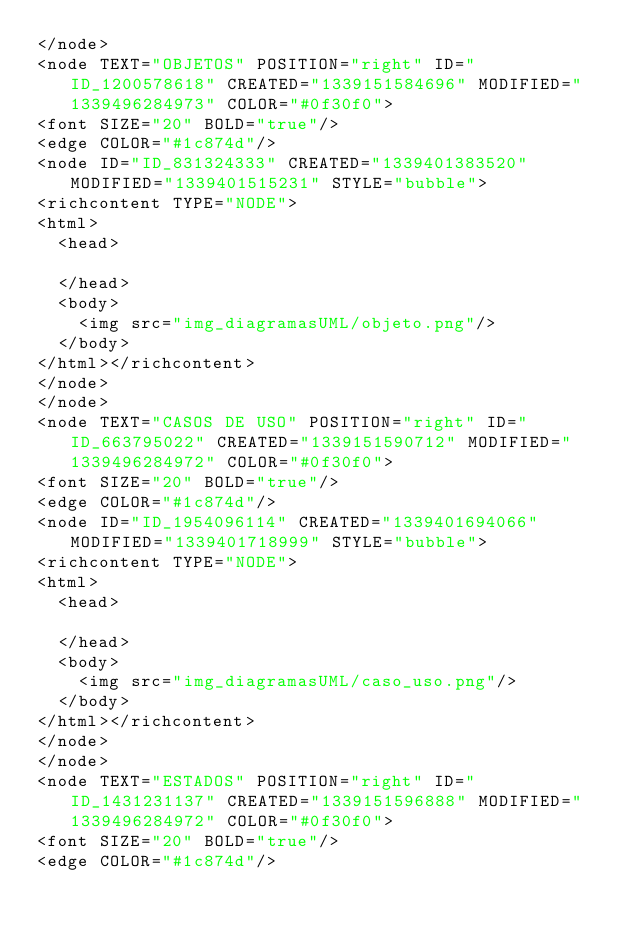<code> <loc_0><loc_0><loc_500><loc_500><_ObjectiveC_></node>
<node TEXT="OBJETOS" POSITION="right" ID="ID_1200578618" CREATED="1339151584696" MODIFIED="1339496284973" COLOR="#0f30f0">
<font SIZE="20" BOLD="true"/>
<edge COLOR="#1c874d"/>
<node ID="ID_831324333" CREATED="1339401383520" MODIFIED="1339401515231" STYLE="bubble">
<richcontent TYPE="NODE">
<html>
  <head>
    
  </head>
  <body>
    <img src="img_diagramasUML/objeto.png"/>
  </body>
</html></richcontent>
</node>
</node>
<node TEXT="CASOS DE USO" POSITION="right" ID="ID_663795022" CREATED="1339151590712" MODIFIED="1339496284972" COLOR="#0f30f0">
<font SIZE="20" BOLD="true"/>
<edge COLOR="#1c874d"/>
<node ID="ID_1954096114" CREATED="1339401694066" MODIFIED="1339401718999" STYLE="bubble">
<richcontent TYPE="NODE">
<html>
  <head>
    
  </head>
  <body>
    <img src="img_diagramasUML/caso_uso.png"/>
  </body>
</html></richcontent>
</node>
</node>
<node TEXT="ESTADOS" POSITION="right" ID="ID_1431231137" CREATED="1339151596888" MODIFIED="1339496284972" COLOR="#0f30f0">
<font SIZE="20" BOLD="true"/>
<edge COLOR="#1c874d"/></code> 